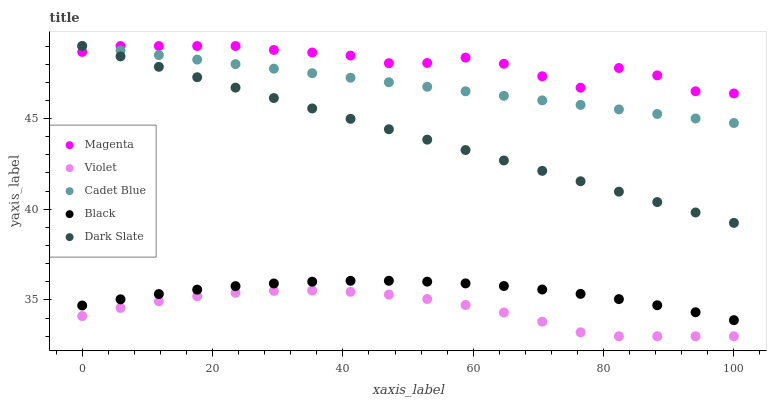Does Violet have the minimum area under the curve?
Answer yes or no. Yes. Does Magenta have the maximum area under the curve?
Answer yes or no. Yes. Does Cadet Blue have the minimum area under the curve?
Answer yes or no. No. Does Cadet Blue have the maximum area under the curve?
Answer yes or no. No. Is Dark Slate the smoothest?
Answer yes or no. Yes. Is Magenta the roughest?
Answer yes or no. Yes. Is Cadet Blue the smoothest?
Answer yes or no. No. Is Cadet Blue the roughest?
Answer yes or no. No. Does Violet have the lowest value?
Answer yes or no. Yes. Does Cadet Blue have the lowest value?
Answer yes or no. No. Does Cadet Blue have the highest value?
Answer yes or no. Yes. Does Black have the highest value?
Answer yes or no. No. Is Black less than Magenta?
Answer yes or no. Yes. Is Black greater than Violet?
Answer yes or no. Yes. Does Magenta intersect Dark Slate?
Answer yes or no. Yes. Is Magenta less than Dark Slate?
Answer yes or no. No. Is Magenta greater than Dark Slate?
Answer yes or no. No. Does Black intersect Magenta?
Answer yes or no. No. 